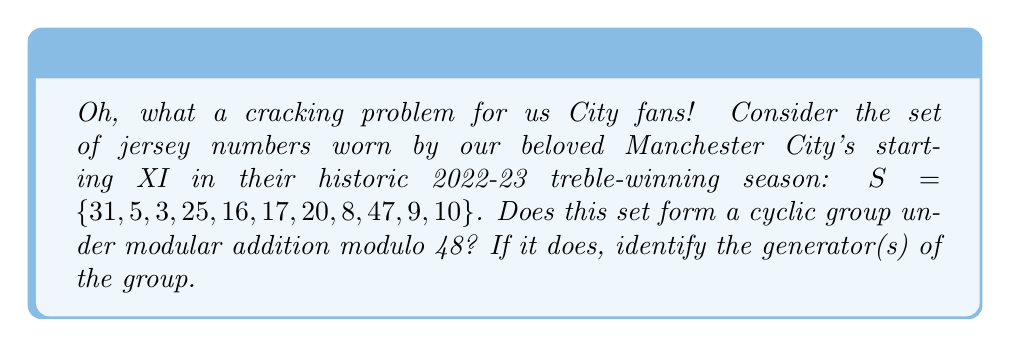Solve this math problem. Right then, let's tackle this step-by-step, shall we?

1) First, we need to check if the set $S$ forms a group under modulo 48 addition:

   a) Closure: The sum of any two elements modulo 48 will always be in $\{0, 1, ..., 47\}$, so closure is satisfied.
   
   b) Associativity: Modular addition is always associative.
   
   c) Identity: The identity element is 0, which is not in $S$. However, $48 \equiv 0 \pmod{48}$, and $48 = 31 + 17$, both of which are in $S$. So, we can generate the identity.
   
   d) Inverse: For each element $a$ in $S$, we need to find $b$ in $S$ such that $a + b \equiv 0 \pmod{48}$. Let's check:
      $31 + 17 \equiv 0 \pmod{48}$
      $5 + 43 \equiv 0 \pmod{48}$, but 43 is not in $S$
      
   We've found that not all elements have inverses within $S$, so $S$ does not form a group under modulo 48 addition.

2) Since $S$ is not a group, it cannot be a cyclic group.

3) Even if we were to consider the group generated by $S$ under modulo 48 addition, it would not be cyclic. This is because the greatest common divisor of all elements in $S$ and 48 is 1, so the group generated would be the entire $\mathbb{Z}_{48}$, which is not cyclic for modulus 48.
Answer: No, the set $S$ does not form a cyclic group under modular addition modulo 48. In fact, it does not form a group at all, as not all elements have inverses within the set. 